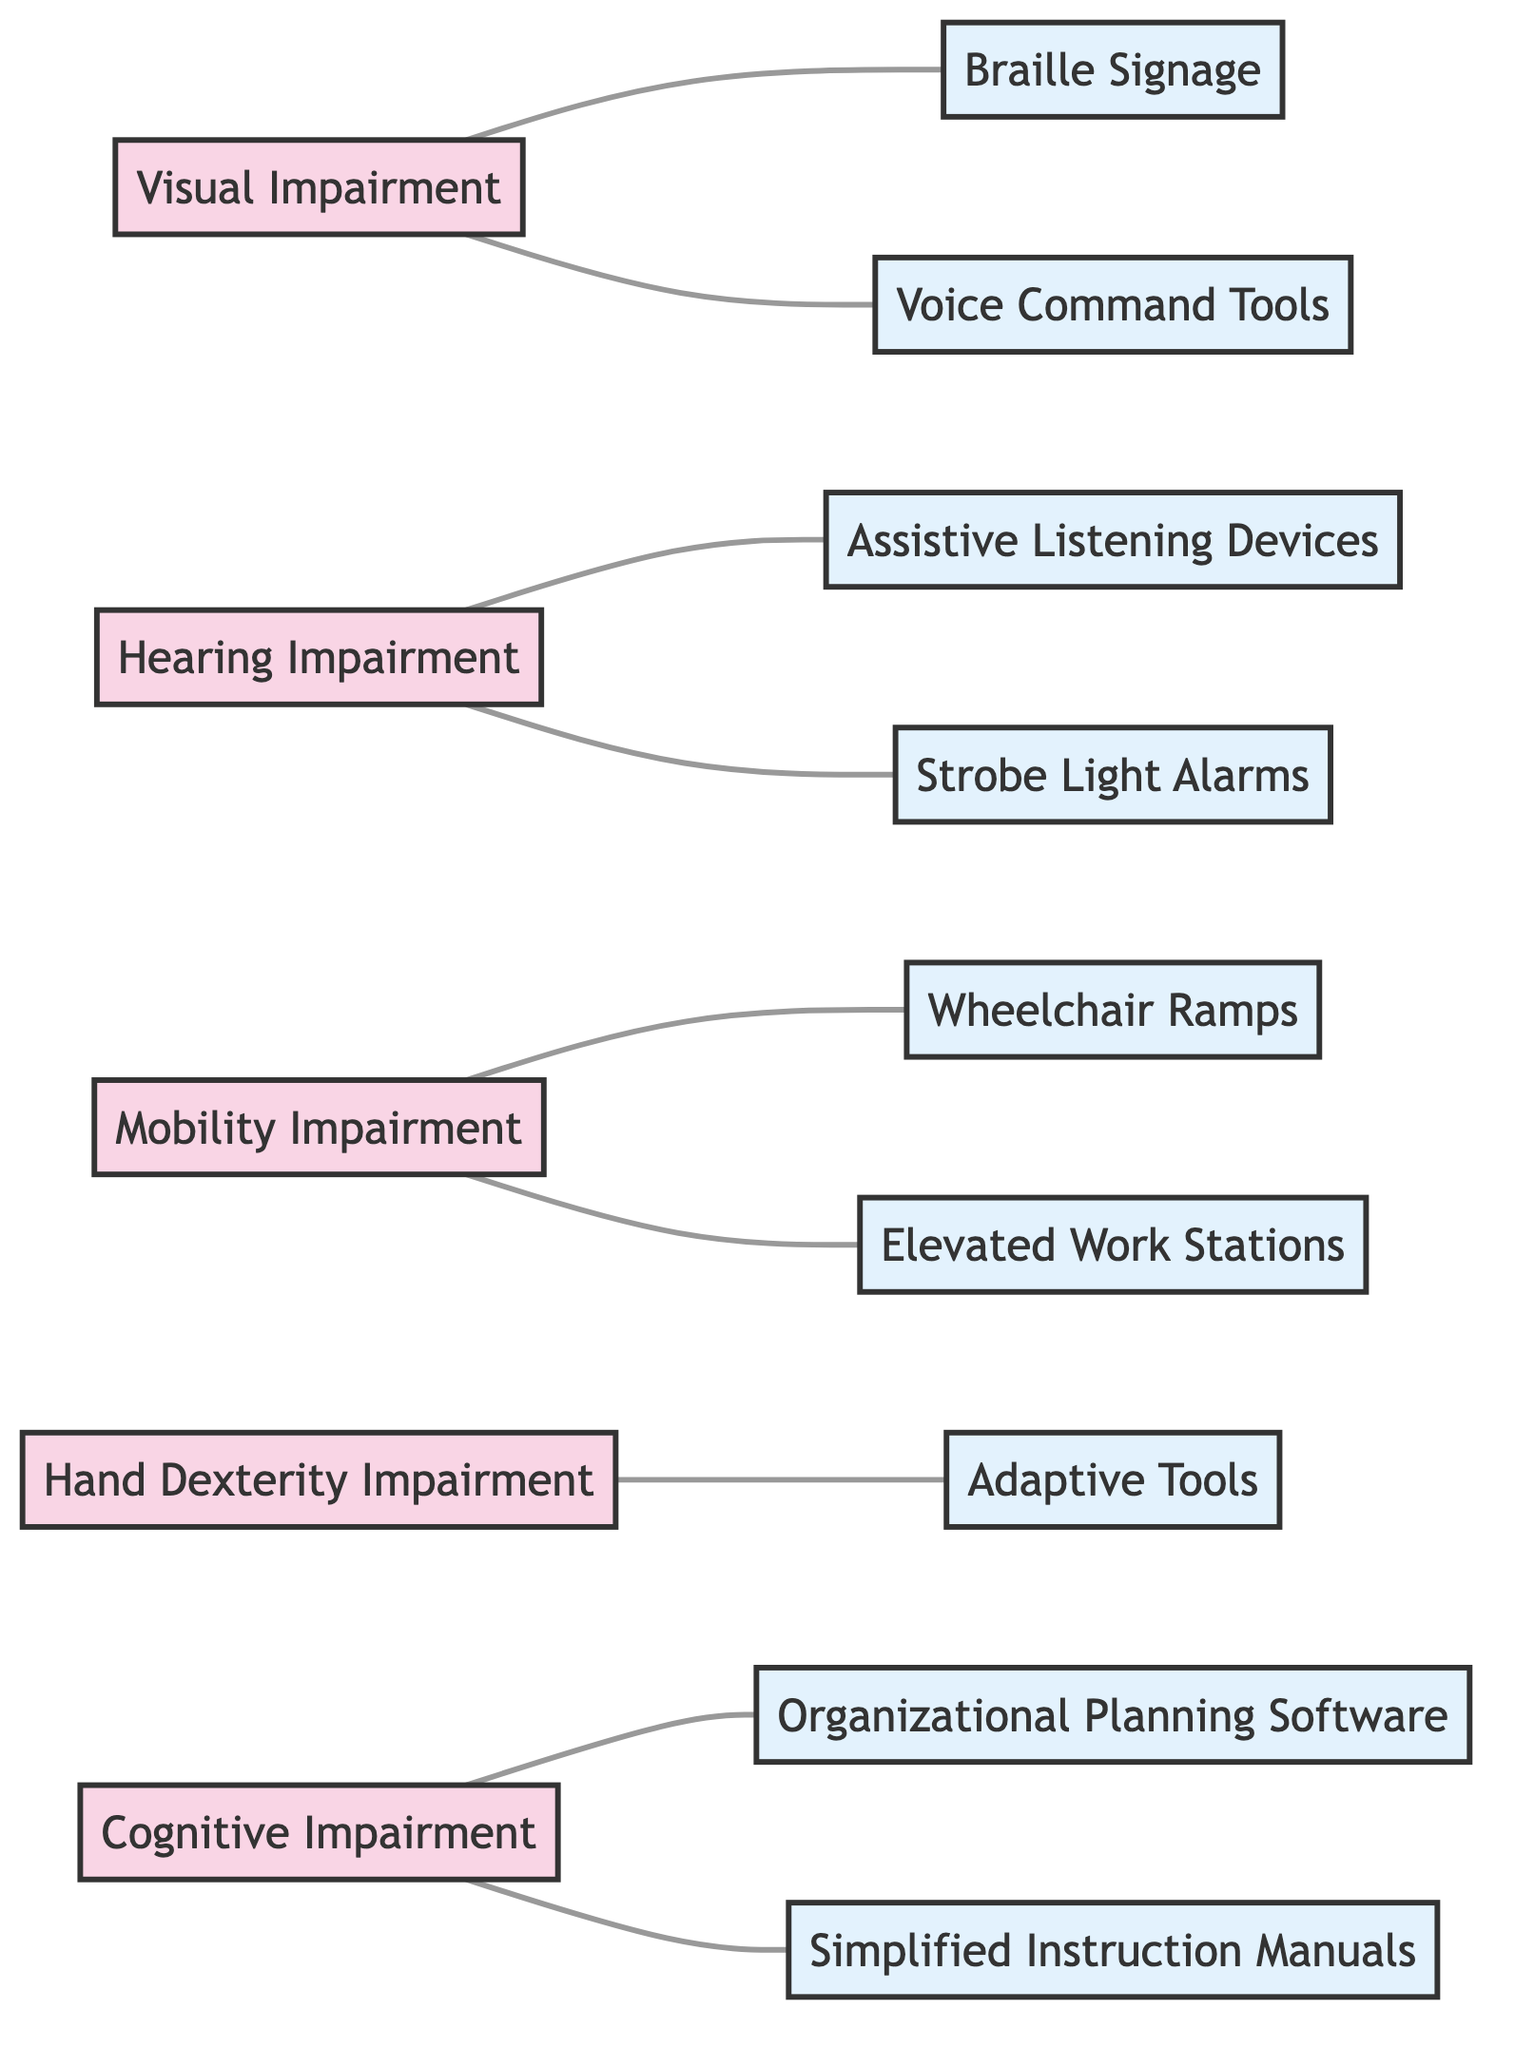What disabilities are linked to Braille Signage? Braille Signage is connected by an edge to Visual Impairment in the diagram, indicating that this specific adjustment is required for individuals with Visual Impairment.
Answer: Visual Impairment Which workplace adjustment is associated with Hearing Impairment? The edge between Hearing Impairment and both Assistive Listening Devices and Strobe Light Alarms shows that these adjustments are needed for workers with Hearing Impairment.
Answer: Assistive Listening Devices, Strobe Light Alarms How many nodes representing disabilities are there in the diagram? By counting the nodes labeled as disabilities (Visual Impairment, Hearing Impairment, Mobility Impairment, Hand Dexterity Impairment, Cognitive Impairment), we find a total of five nodes representing disabilities.
Answer: 5 What is the relationship between Hand Dexterity Impairment and adjustments? The diagram shows that Hand Dexterity Impairment is linked to Adaptive Tools, indicating this is the required adjustment for individuals with this disability.
Answer: Adaptive Tools Which adjustment is necessary for those with Cognitive Impairment? Looking at the edges, Cognitive Impairment is related to both Organizational Planning Software and Simplified Instruction Manuals, meaning both are necessary for individuals with this condition.
Answer: Organizational Planning Software, Simplified Instruction Manuals How many workplace adjustments are associated with Mobility Impairment? The edges show two connections—one to Wheelchair Ramps and one to Elevated Work Stations—indicating two specific adjustments needed for Mobility Impairment.
Answer: 2 Can individuals with Visual Impairment use Voice Command Tools? The edge connecting Visual Impairment to Voice Command Tools indicates that this adjustment is also applicable for individuals with Visual Impairment to facilitate their work.
Answer: Yes What are the total number of edges in the diagram? By counting the connections (edges) between the disabilities and adjustments, we find that there are eight edges present in the entire diagram.
Answer: 8 Which disability has the most adjustments connected? Analyzing the connections, Cognitive Impairment has two adjustments (Organizational Planning Software and Simplified Instruction Manuals), which is the most compared to other disabilities.
Answer: Cognitive Impairment 